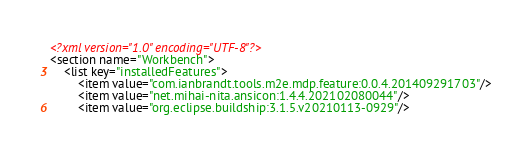Convert code to text. <code><loc_0><loc_0><loc_500><loc_500><_XML_><?xml version="1.0" encoding="UTF-8"?>
<section name="Workbench">
	<list key="installedFeatures">
		<item value="com.ianbrandt.tools.m2e.mdp.feature:0.0.4.201409291703"/>
		<item value="net.mihai-nita.ansicon:1.4.4.202102080044"/>
		<item value="org.eclipse.buildship:3.1.5.v20210113-0929"/></code> 